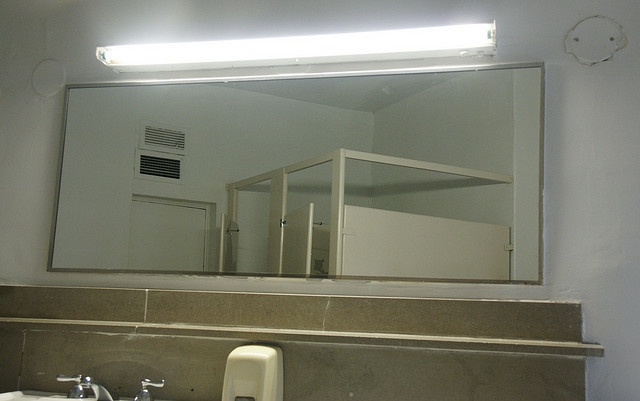Describe the objects in this image and their specific colors. I can see a sink in gray, black, darkgray, and beige tones in this image. 